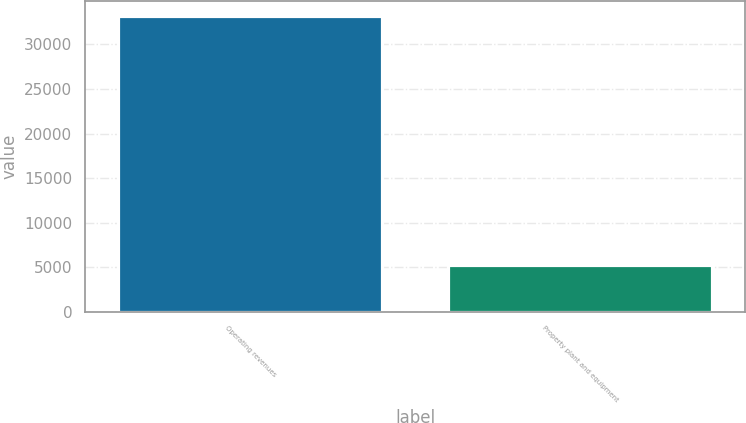<chart> <loc_0><loc_0><loc_500><loc_500><bar_chart><fcel>Operating revenues<fcel>Property plant and equipment<nl><fcel>33233<fcel>5319<nl></chart> 